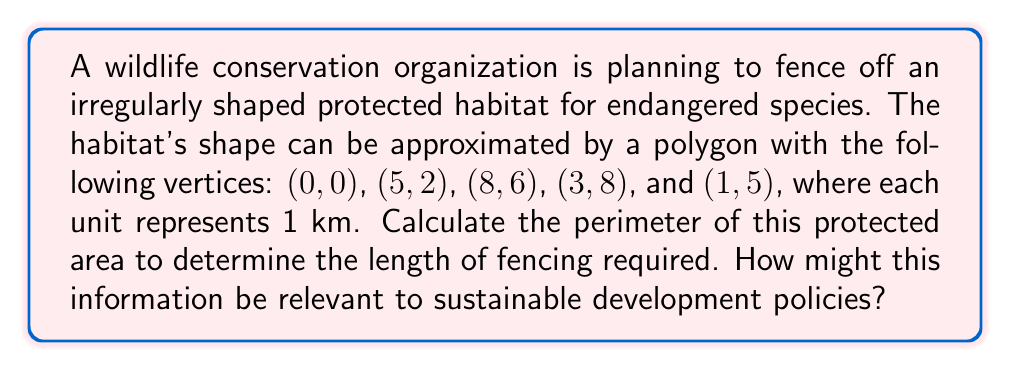Can you solve this math problem? To solve this problem, we'll follow these steps:

1) First, we need to calculate the distance between each pair of consecutive vertices. We can use the distance formula:

   $$d = \sqrt{(x_2-x_1)^2 + (y_2-y_1)^2}$$

2) Let's calculate each side:

   Side 1 (0,0) to (5,2):
   $$d_1 = \sqrt{(5-0)^2 + (2-0)^2} = \sqrt{25 + 4} = \sqrt{29} \approx 5.39 \text{ km}$$

   Side 2 (5,2) to (8,6):
   $$d_2 = \sqrt{(8-5)^2 + (6-2)^2} = \sqrt{9 + 16} = 5 \text{ km}$$

   Side 3 (8,6) to (3,8):
   $$d_3 = \sqrt{(3-8)^2 + (8-6)^2} = \sqrt{25 + 4} = \sqrt{29} \approx 5.39 \text{ km}$$

   Side 4 (3,8) to (1,5):
   $$d_4 = \sqrt{(1-3)^2 + (5-8)^2} = \sqrt{4 + 9} = \sqrt{13} \approx 3.61 \text{ km}$$

   Side 5 (1,5) to (0,0):
   $$d_5 = \sqrt{(0-1)^2 + (0-5)^2} = \sqrt{1 + 25} = \sqrt{26} \approx 5.10 \text{ km}$$

3) The perimeter is the sum of all these distances:

   $$\text{Perimeter} = d_1 + d_2 + d_3 + d_4 + d_5$$
   $$\approx 5.39 + 5 + 5.39 + 3.61 + 5.10 = 24.49 \text{ km}$$

This information is relevant to sustainable development policies as it helps in resource allocation and budgeting for conservation efforts. Knowing the exact perimeter allows for precise planning of fencing materials and installation costs, which is crucial for efficient use of limited resources in wildlife protection projects. It also aids in assessing the impact on surrounding areas and planning for wildlife corridors, contributing to more comprehensive and sustainable land-use policies.
Answer: 24.49 km 